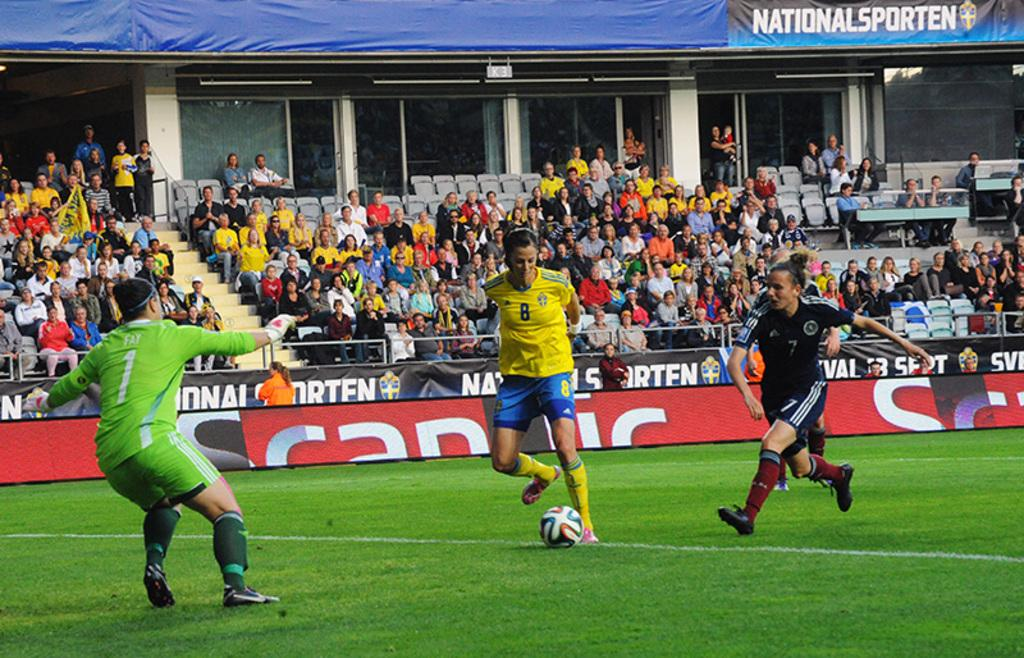<image>
Present a compact description of the photo's key features. A soccer player in a yellow shirt with the number eight on his chest is about to shoot the ball. 